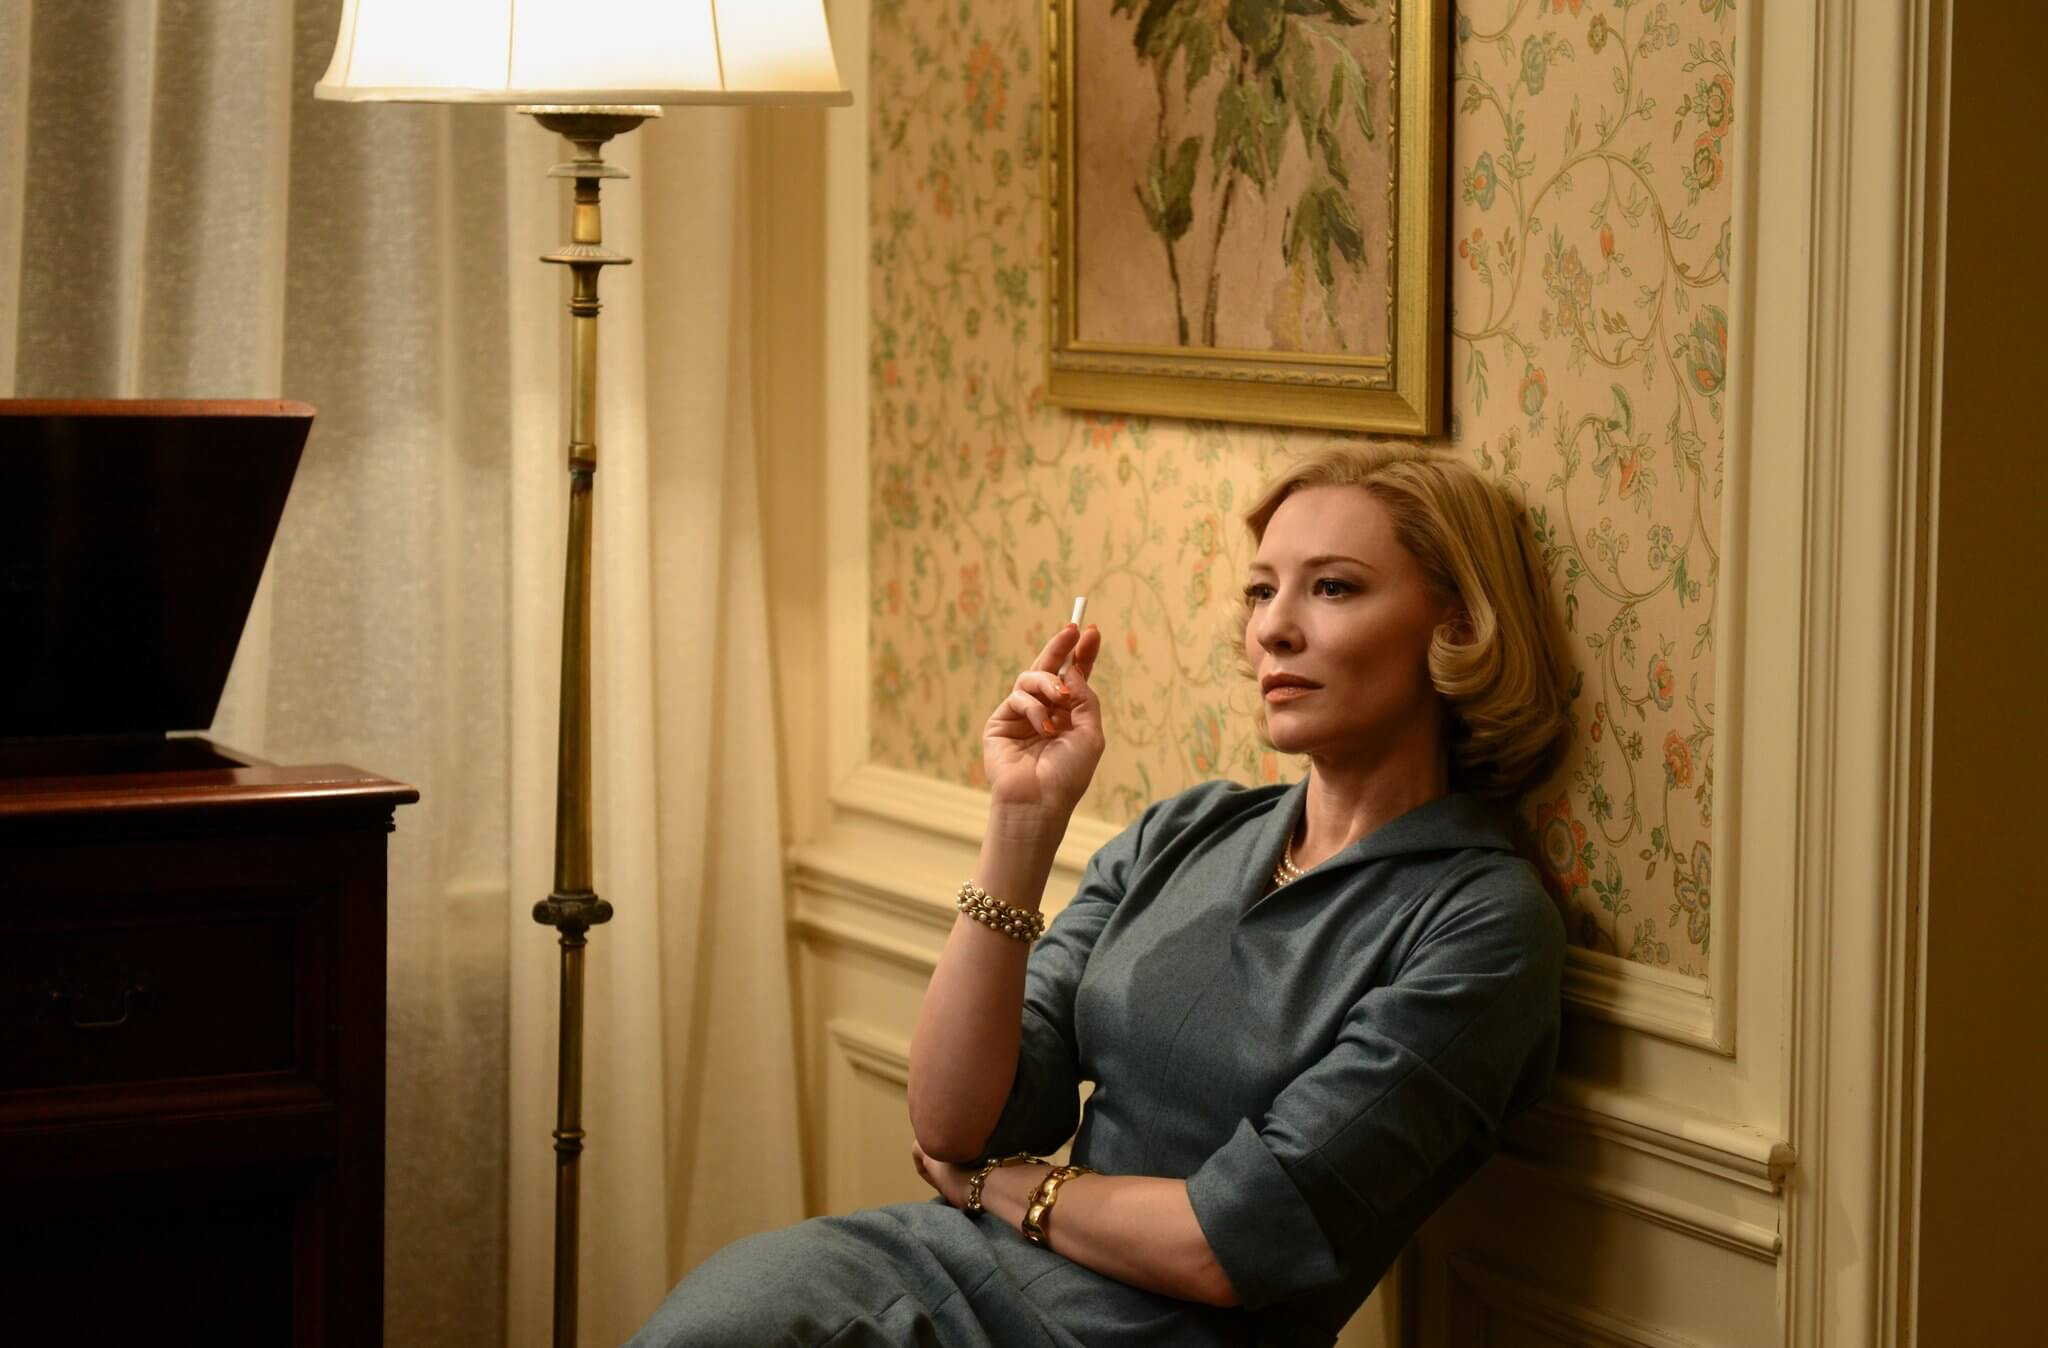Describe the room's decor and what it reveals about the character. The room is adorned with intricate floral wallpaper, suggesting an appreciation for classic, vintage aesthetics. The beige armchair and wooden desk indicate a preference for timeless, well-crafted furniture. The lamp emits a gentle, warm light, creating an intimate and inviting atmosphere. These elements collectively reveal a character who values tradition, has a keen eye for detail, and perhaps harbors a strong sense of nostalgia. The careful curation of the room suggests a deep emotional connection to the past and a desire to create a serene, reflective environment. If this room could narrate the story of its existence, what would it say? This room would narrate tales of countless moments of quiet contemplation and significant conversations. It has witnessed the slow burn of many cigarettes, a symbol of the times when decisions weighing heavily on the mind found temporary escape in smoke. The floral wallpaper has absorbed the soft whispers of secrets, the laughter of joyful reunions, and the somber tones of farewells. Each piece of furniture, from the elegant armchair to the sturdy wooden desk, has its own story, shaped by those who came before, leaving behind imprints of their lives. The lamp has cast light on countless pages of old, read during tranquil nights, offering its warmth and comfort. Together, these elements weave a rich tapestry of a life lived deeply and thoughtfully within these walls. 